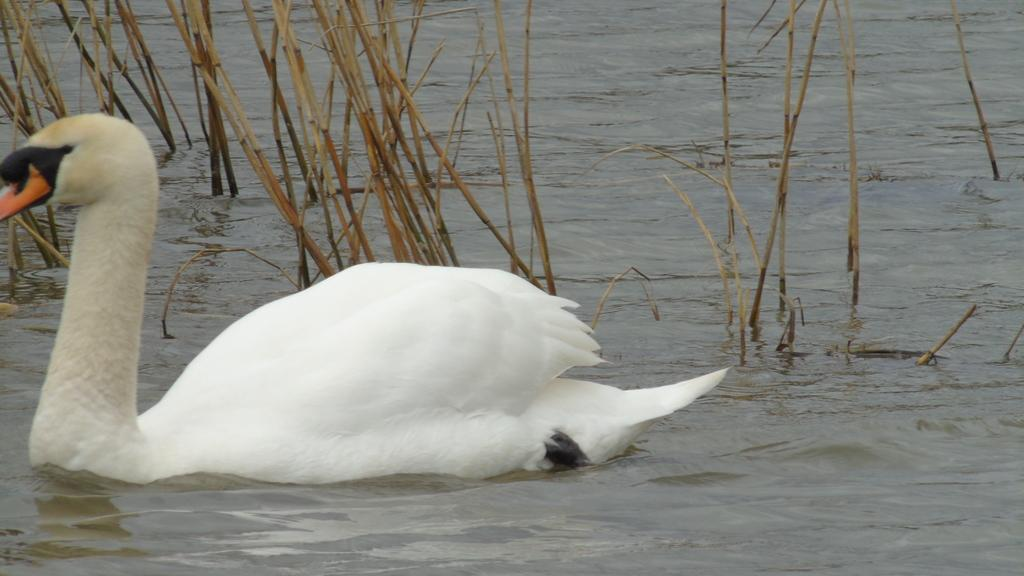What type of animal can be seen in the image? There is a bird in the image. Where is the bird located? The bird is in the water. What color is the bird? The bird is white in color. What can be seen in the background of the image? There is dried grass in the background of the image. What type of light is being used to illuminate the bird in the image? There is no specific light source mentioned or visible in the image, so it is not possible to determine the type of light being used. 